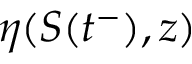Convert formula to latex. <formula><loc_0><loc_0><loc_500><loc_500>\eta ( S ( t ^ { - } ) , z )</formula> 